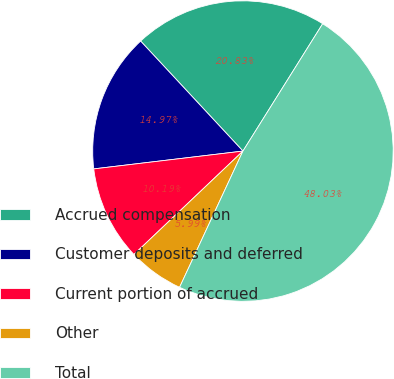<chart> <loc_0><loc_0><loc_500><loc_500><pie_chart><fcel>Accrued compensation<fcel>Customer deposits and deferred<fcel>Current portion of accrued<fcel>Other<fcel>Total<nl><fcel>20.83%<fcel>14.97%<fcel>10.19%<fcel>5.99%<fcel>48.03%<nl></chart> 